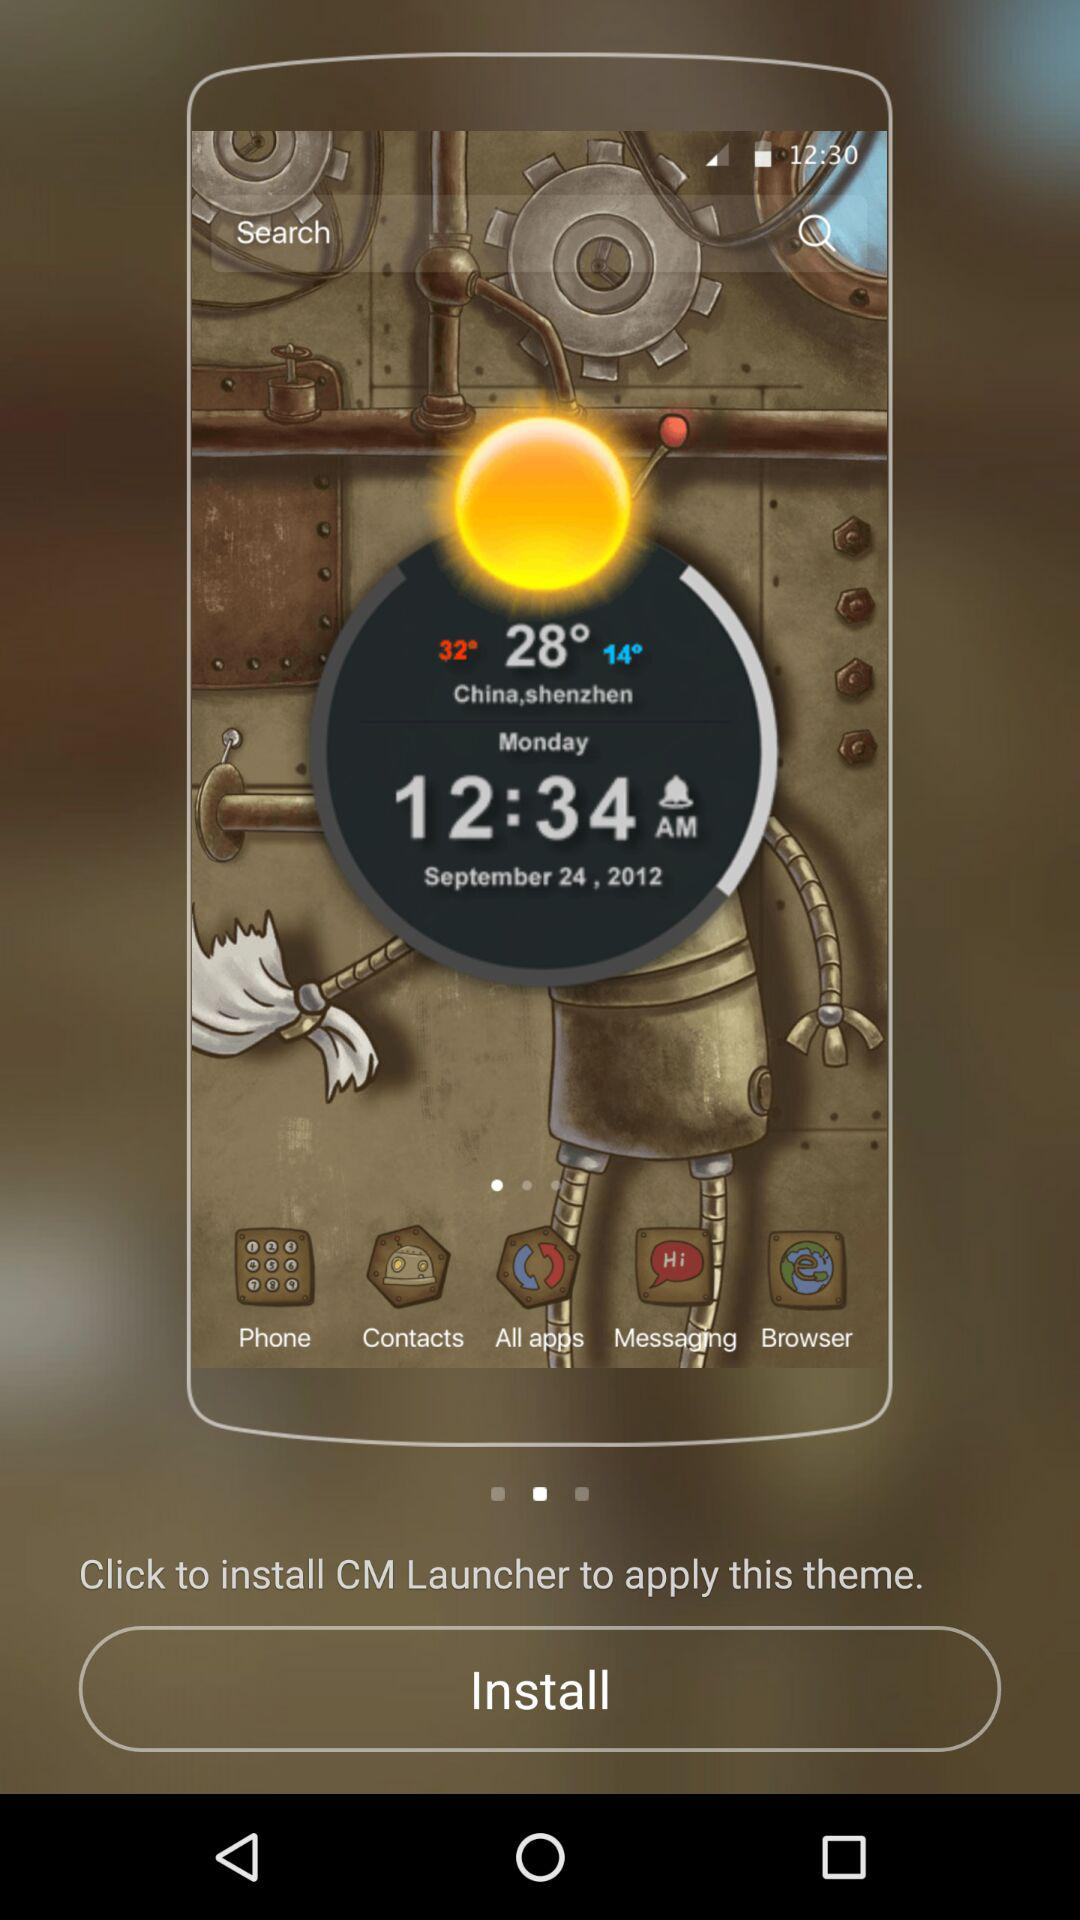What is the time? The time is 12:34 am. 